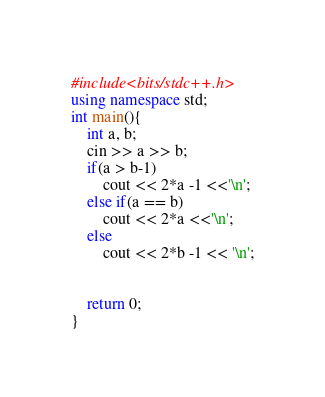<code> <loc_0><loc_0><loc_500><loc_500><_C++_>#include<bits/stdc++.h>
using namespace std;
int main(){
	int a, b;
    cin >> a >> b;
    if(a > b-1)
    	cout << 2*a -1 <<'\n';
    else if(a == b)
    	cout << 2*a <<'\n';
    else
    	cout << 2*b -1 << '\n';


	return 0;
}</code> 